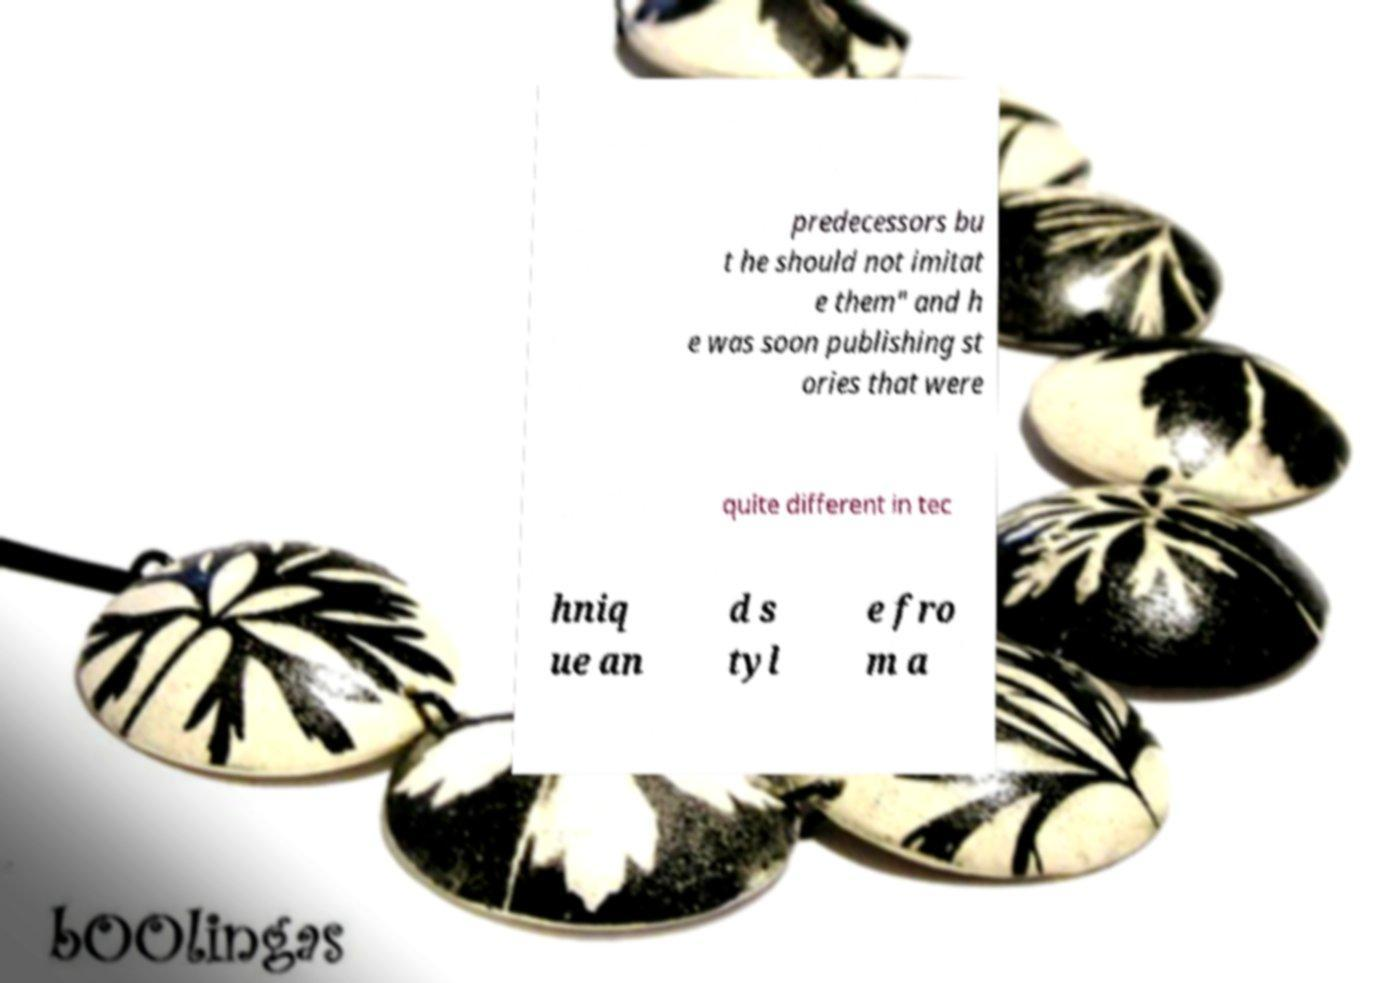Can you read and provide the text displayed in the image?This photo seems to have some interesting text. Can you extract and type it out for me? predecessors bu t he should not imitat e them" and h e was soon publishing st ories that were quite different in tec hniq ue an d s tyl e fro m a 